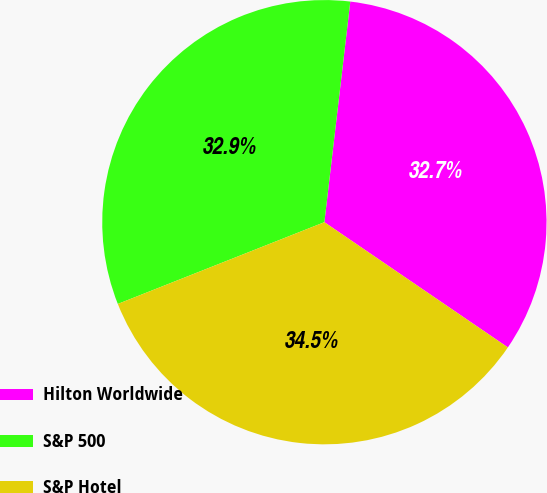Convert chart to OTSL. <chart><loc_0><loc_0><loc_500><loc_500><pie_chart><fcel>Hilton Worldwide<fcel>S&P 500<fcel>S&P Hotel<nl><fcel>32.67%<fcel>32.86%<fcel>34.47%<nl></chart> 